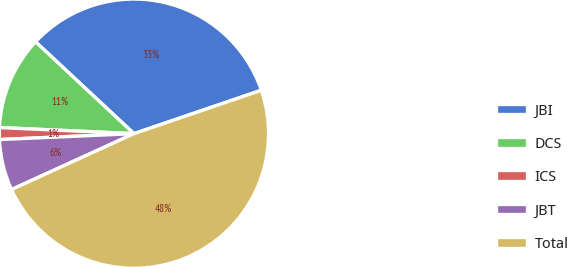Convert chart to OTSL. <chart><loc_0><loc_0><loc_500><loc_500><pie_chart><fcel>JBI<fcel>DCS<fcel>ICS<fcel>JBT<fcel>Total<nl><fcel>32.82%<fcel>11.23%<fcel>1.42%<fcel>6.12%<fcel>48.41%<nl></chart> 